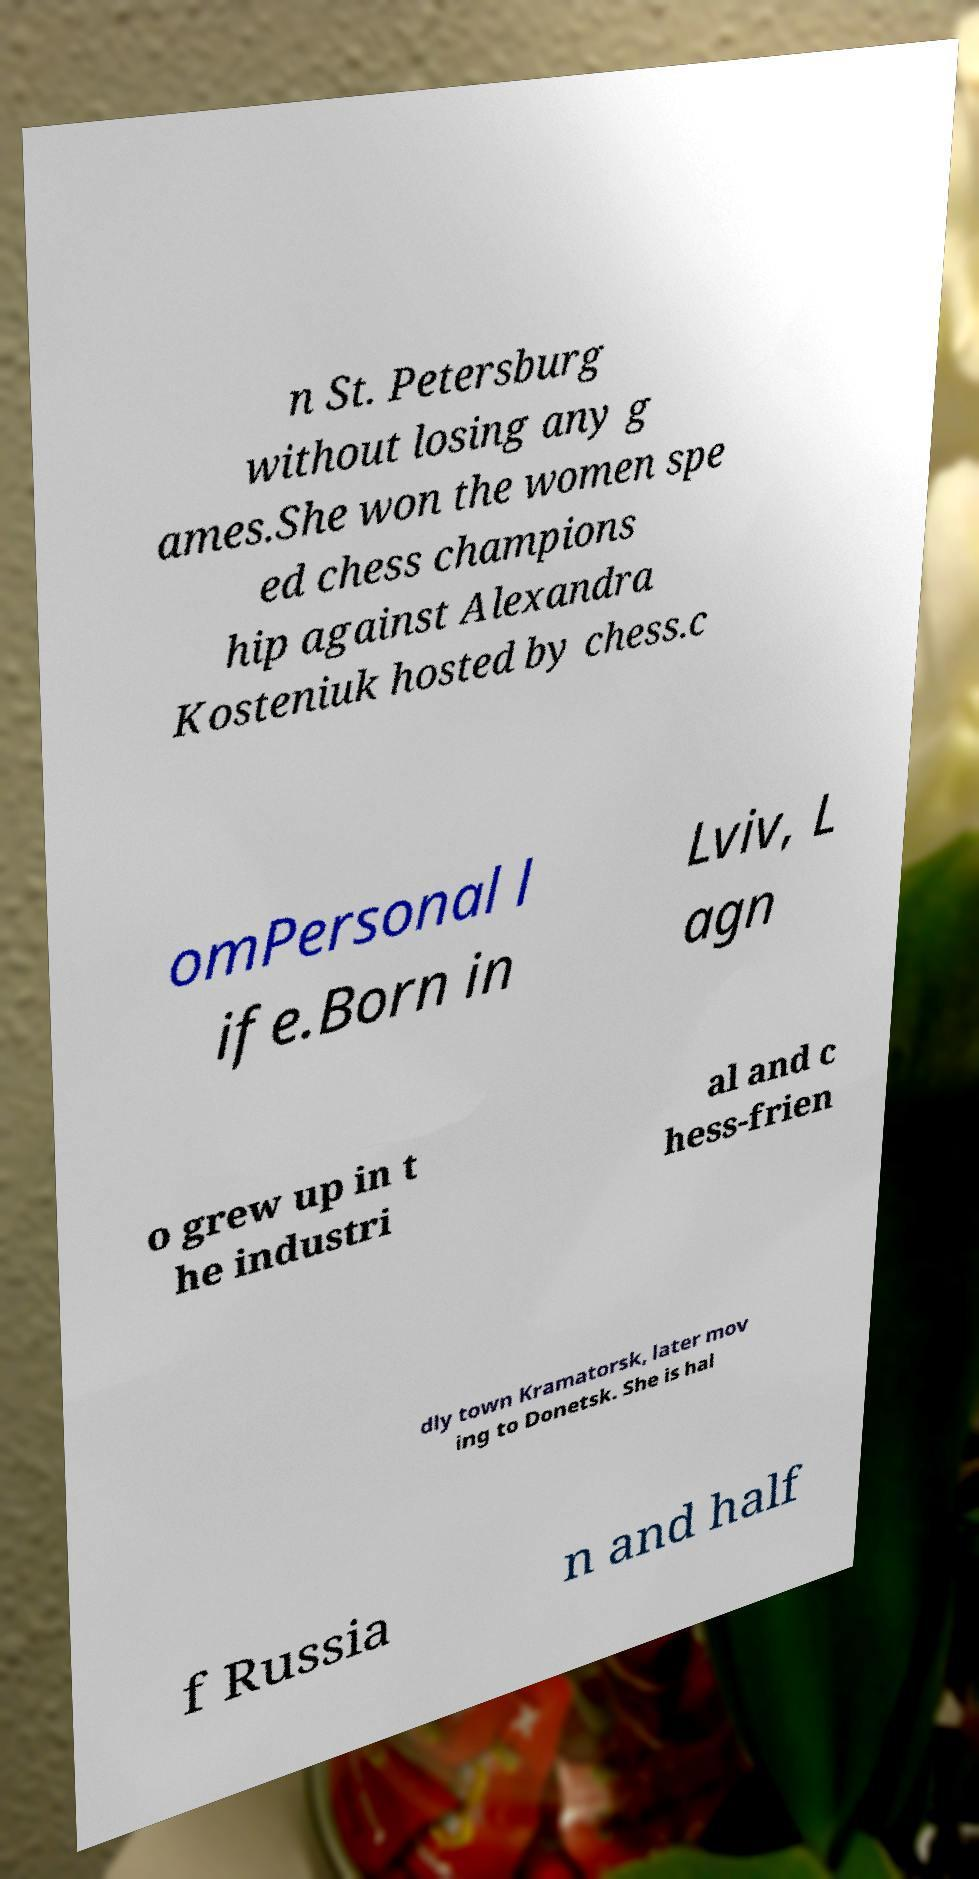For documentation purposes, I need the text within this image transcribed. Could you provide that? n St. Petersburg without losing any g ames.She won the women spe ed chess champions hip against Alexandra Kosteniuk hosted by chess.c omPersonal l ife.Born in Lviv, L agn o grew up in t he industri al and c hess-frien dly town Kramatorsk, later mov ing to Donetsk. She is hal f Russia n and half 